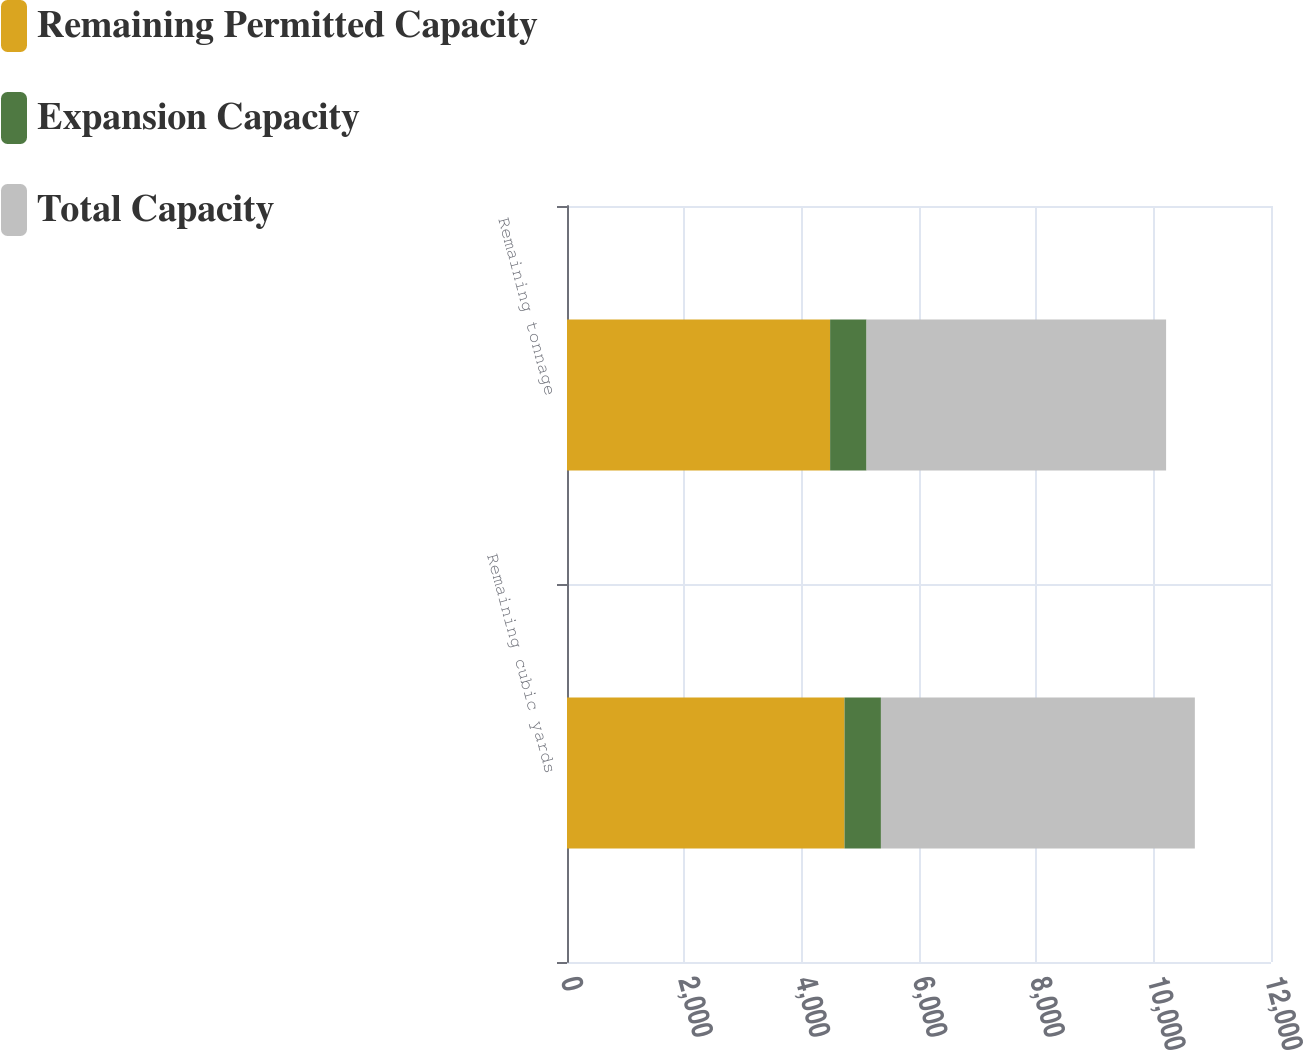Convert chart to OTSL. <chart><loc_0><loc_0><loc_500><loc_500><stacked_bar_chart><ecel><fcel>Remaining cubic yards<fcel>Remaining tonnage<nl><fcel>Remaining Permitted Capacity<fcel>4730<fcel>4485<nl><fcel>Expansion Capacity<fcel>621<fcel>621<nl><fcel>Total Capacity<fcel>5351<fcel>5106<nl></chart> 